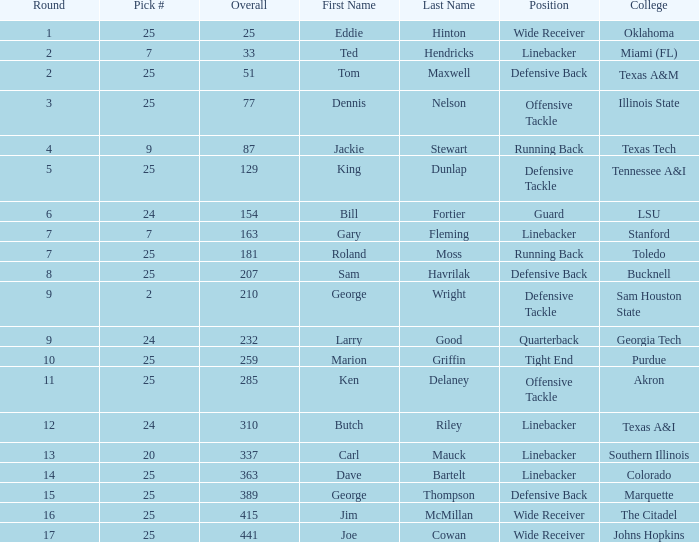College of lsu has how many rounds? 1.0. 